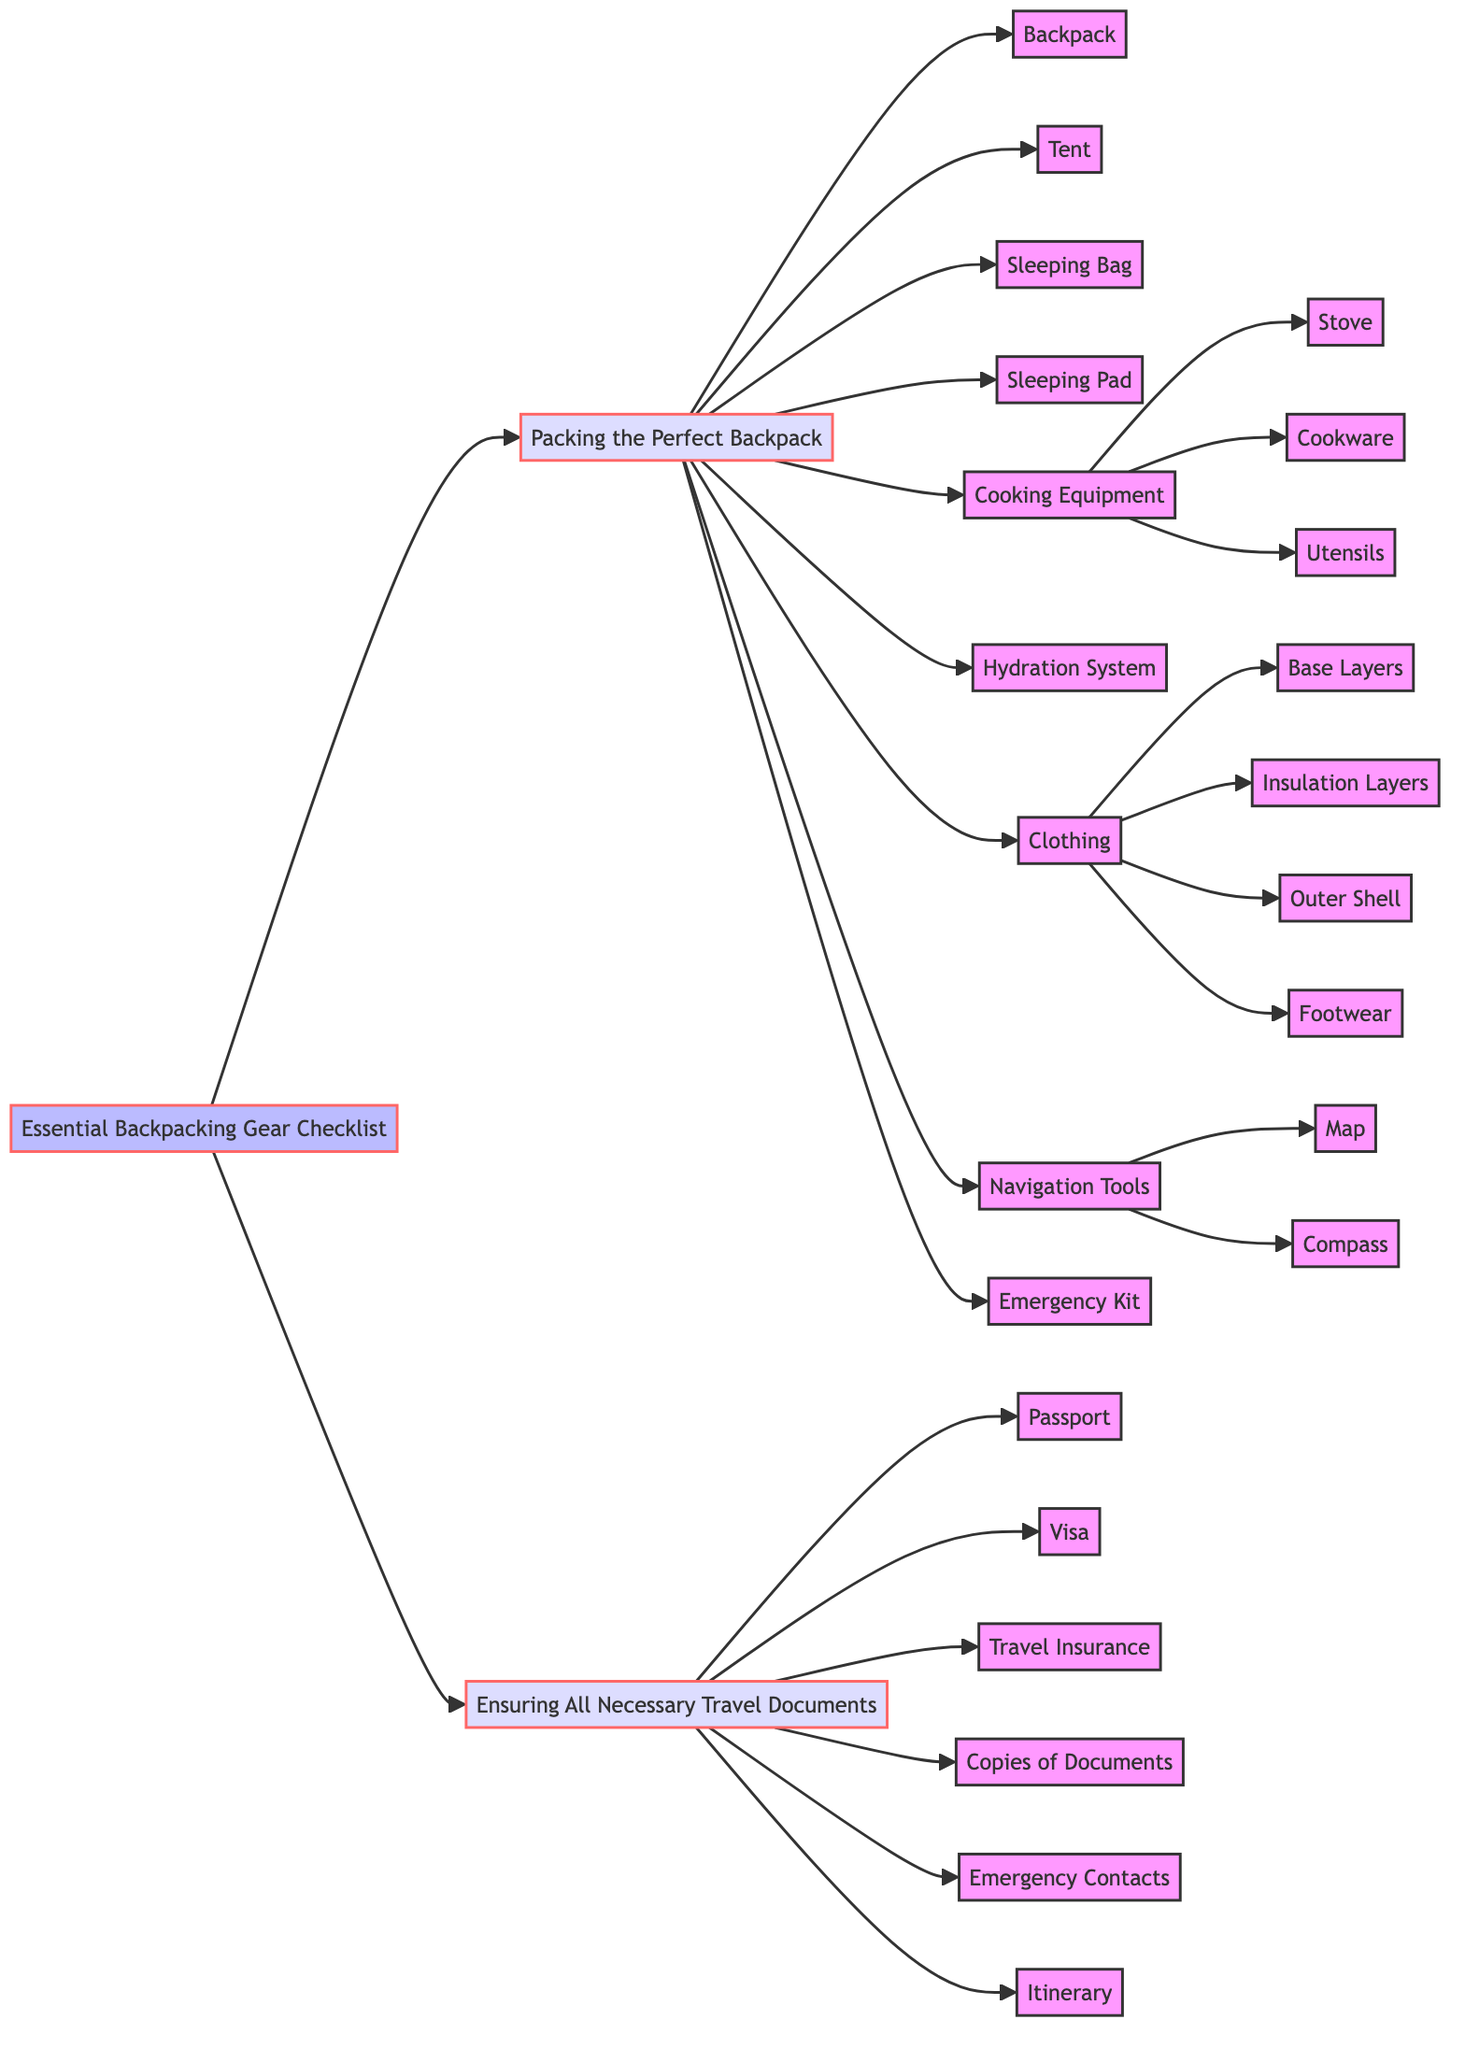What is the brand of the backpack listed? The diagram shows that the backpack is "Osprey Atmos AG 65." This is located under the first major category, "Packing the Perfect Backpack," specifically under the "Backpack" node.
Answer: Osprey Atmos AG 65 How many items are listed under "Packing the Perfect Backpack"? Counting the nodes that directly branch off from "Packing the Perfect Backpack," there are nine items, which include the backpack, tent, sleeping bag, sleeping pad, cooking equipment, hydration system, clothing, navigation tools, and emergency kit.
Answer: 9 What type of stove is recommended in the cooking equipment section? The diagram specifies "MSR PocketRocket 2" as the stove in the cooking equipment node. This node is a sub-node branching off the "Cooking Equipment" category.
Answer: MSR PocketRocket 2 What is the first item listed under clothing? Under the clothing section, the first node is "Base Layers," which refers to "Smartwool Merino 150." This can be found in the sub-nodes branching off "Clothing."
Answer: Base Layers How many components are listed under the navigation tools? The navigation tools section has two components: "Map" and "Compass." This information can be found directly in the navigation tools node.
Answer: 2 What is the relationship between "Packing the Perfect Backpack" and "Ensuring All Necessary Travel Documents"? Both "Packing the Perfect Backpack" and "Ensuring All Necessary Travel Documents" are primary nodes branching directly from the "Essential Backpacking Gear Checklist," indicating they are both essential categories of gear and necessary documentation for backpacking.
Answer: They are both primary categories Which item is classified as an emergency kit? The diagram indicates that the item is "Adventure Medical Kits Ultralight/Watertight .7." This is found under the "Emergency Kit" node within the "Packing the Perfect Backpack" category.
Answer: Adventure Medical Kits Ultralight/Watertight .7 What is required if a visa is applicable? The diagram states that a "Schengen Visa" is required if applicable, which is located under the "Ensuring All Necessary Travel Documents" section.
Answer: Schengen Visa What documents should have copies according to the checklist? The diagram specifies that copies of the passport, visa, insurance, and reservation confirmations are required, as listed in the "Copies of Important Documents" node.
Answer: Passport, Visa, Insurance, Reservation Confirmations 